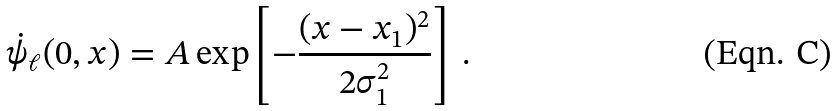Convert formula to latex. <formula><loc_0><loc_0><loc_500><loc_500>\dot { \psi } _ { \ell } ( 0 , x ) = A \exp \left [ - \frac { ( x - x _ { 1 } ) ^ { 2 } } { 2 \sigma _ { 1 } ^ { 2 } } \right ] \ .</formula> 